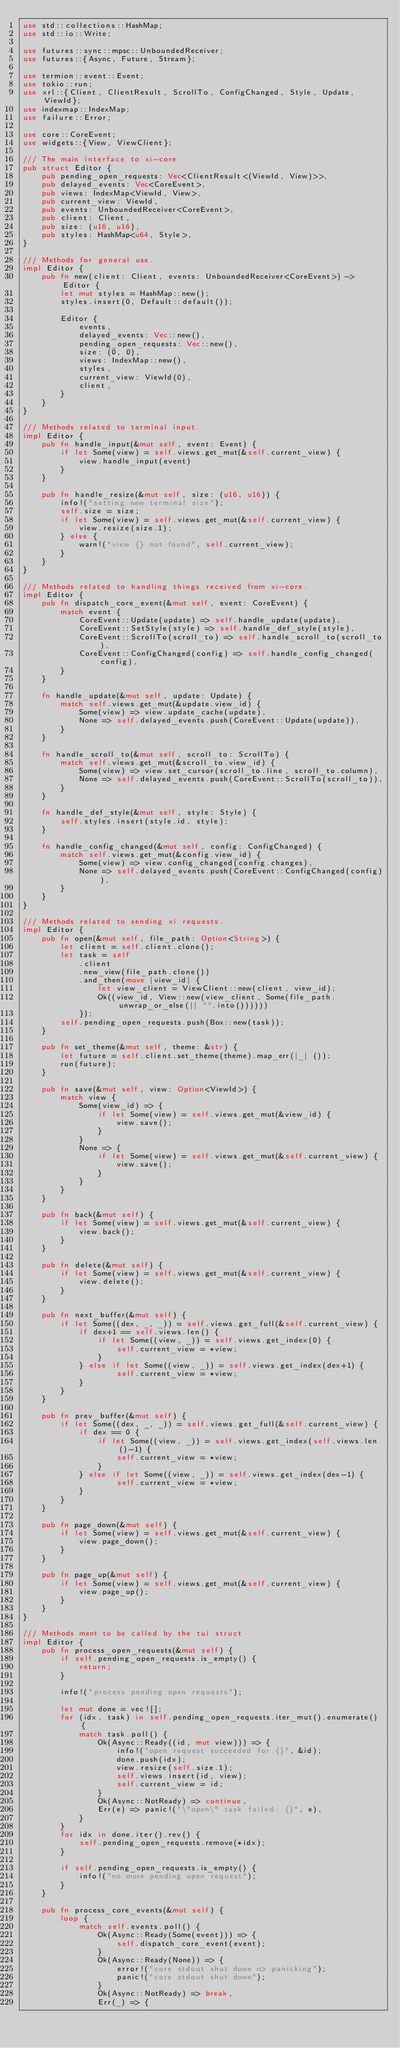Convert code to text. <code><loc_0><loc_0><loc_500><loc_500><_Rust_>use std::collections::HashMap;
use std::io::Write;

use futures::sync::mpsc::UnboundedReceiver;
use futures::{Async, Future, Stream};

use termion::event::Event;
use tokio::run;
use xrl::{Client, ClientResult, ScrollTo, ConfigChanged, Style, Update, ViewId};
use indexmap::IndexMap;
use failure::Error;

use core::CoreEvent;
use widgets::{View, ViewClient};

/// The main interface to xi-core
pub struct Editor {
    pub pending_open_requests: Vec<ClientResult<(ViewId, View)>>,
    pub delayed_events: Vec<CoreEvent>,
    pub views: IndexMap<ViewId, View>,
    pub current_view: ViewId,
    pub events: UnboundedReceiver<CoreEvent>,
    pub client: Client,
    pub size: (u16, u16),
    pub styles: HashMap<u64, Style>,
}

/// Methods for general use.
impl Editor {
    pub fn new(client: Client, events: UnboundedReceiver<CoreEvent>) -> Editor {
        let mut styles = HashMap::new();
        styles.insert(0, Default::default());

        Editor {
            events,
            delayed_events: Vec::new(),
            pending_open_requests: Vec::new(),
            size: (0, 0),
            views: IndexMap::new(),
            styles,
            current_view: ViewId(0),
            client,
        }
    }
}

/// Methods related to terminal input.
impl Editor {
    pub fn handle_input(&mut self, event: Event) {
        if let Some(view) = self.views.get_mut(&self.current_view) {
            view.handle_input(event)
        }
    }

    pub fn handle_resize(&mut self, size: (u16, u16)) {
        info!("setting new terminal size");
        self.size = size;
        if let Some(view) = self.views.get_mut(&self.current_view) {
            view.resize(size.1);
        } else {
            warn!("view {} not found", self.current_view);
        }
    }
}

/// Methods related to handling things received from xi-core.
impl Editor {
    pub fn dispatch_core_event(&mut self, event: CoreEvent) {
        match event {
            CoreEvent::Update(update) => self.handle_update(update),
            CoreEvent::SetStyle(style) => self.handle_def_style(style),
            CoreEvent::ScrollTo(scroll_to) => self.handle_scroll_to(scroll_to),
            CoreEvent::ConfigChanged(config) => self.handle_config_changed(config),
        }
    }

    fn handle_update(&mut self, update: Update) {
        match self.views.get_mut(&update.view_id) {
            Some(view) => view.update_cache(update),
            None => self.delayed_events.push(CoreEvent::Update(update)),
        }
    }

    fn handle_scroll_to(&mut self, scroll_to: ScrollTo) {
        match self.views.get_mut(&scroll_to.view_id) {
            Some(view) => view.set_cursor(scroll_to.line, scroll_to.column),
            None => self.delayed_events.push(CoreEvent::ScrollTo(scroll_to)),
        }
    }

    fn handle_def_style(&mut self, style: Style) {
        self.styles.insert(style.id, style);
    }

    fn handle_config_changed(&mut self, config: ConfigChanged) {
        match self.views.get_mut(&config.view_id) {
            Some(view) => view.config_changed(config.changes),
            None => self.delayed_events.push(CoreEvent::ConfigChanged(config)),
        }
    }
}

/// Methods related to sending xi requests.
impl Editor {
    pub fn open(&mut self, file_path: Option<String>) {
        let client = self.client.clone();
        let task = self
            .client
            .new_view(file_path.clone())
            .and_then(move |view_id| {
                let view_client = ViewClient::new(client, view_id);
                Ok((view_id, View::new(view_client, Some(file_path.unwrap_or_else(|| "".into())))))
            });
        self.pending_open_requests.push(Box::new(task));
    }

    pub fn set_theme(&mut self, theme: &str) {
        let future = self.client.set_theme(theme).map_err(|_| ());
        run(future);
    }

    pub fn save(&mut self, view: Option<ViewId>) {
        match view {
            Some(view_id) => {
                if let Some(view) = self.views.get_mut(&view_id) {
                    view.save();
                }
            }
            None => {
                if let Some(view) = self.views.get_mut(&self.current_view) {
                    view.save();
                }
            }
        }
    }

    pub fn back(&mut self) {
        if let Some(view) = self.views.get_mut(&self.current_view) {
            view.back();
        }
    }

    pub fn delete(&mut self) {
        if let Some(view) = self.views.get_mut(&self.current_view) {
            view.delete();
        }
    }

    pub fn next_buffer(&mut self) {
        if let Some((dex, _, _)) = self.views.get_full(&self.current_view) {
            if dex+1 == self.views.len() {
                if let Some((view, _)) = self.views.get_index(0) {
                    self.current_view = *view;
                }
            } else if let Some((view, _)) = self.views.get_index(dex+1) {
                    self.current_view = *view;
            }
        }
    }

    pub fn prev_buffer(&mut self) {
        if let Some((dex, _, _)) = self.views.get_full(&self.current_view) {
            if dex == 0 {
                if let Some((view, _)) = self.views.get_index(self.views.len()-1) {
                    self.current_view = *view;
                }
            } else if let Some((view, _)) = self.views.get_index(dex-1) {
                    self.current_view = *view;
            }
        }
    }

    pub fn page_down(&mut self) {
        if let Some(view) = self.views.get_mut(&self.current_view) {
            view.page_down();
        }
    }

    pub fn page_up(&mut self) {
        if let Some(view) = self.views.get_mut(&self.current_view) {
            view.page_up();
        }
    }
}

/// Methods ment to be called by the tui struct
impl Editor {
    pub fn process_open_requests(&mut self) {
        if self.pending_open_requests.is_empty() {
            return;
        }

        info!("process pending open requests");

        let mut done = vec![];
        for (idx, task) in self.pending_open_requests.iter_mut().enumerate() {
            match task.poll() {
                Ok(Async::Ready((id, mut view))) => {
                    info!("open request succeeded for {}", &id);
                    done.push(idx);
                    view.resize(self.size.1);
                    self.views.insert(id, view);
                    self.current_view = id;
                }
                Ok(Async::NotReady) => continue,
                Err(e) => panic!("\"open\" task failed: {}", e),
            }
        }
        for idx in done.iter().rev() {
            self.pending_open_requests.remove(*idx);
        }

        if self.pending_open_requests.is_empty() {
            info!("no more pending open request");
        }
    }

    pub fn process_core_events(&mut self) {
        loop {
            match self.events.poll() {
                Ok(Async::Ready(Some(event))) => {
                    self.dispatch_core_event(event);
                }
                Ok(Async::Ready(None)) => {
                    error!("core stdout shut down => panicking");
                    panic!("core stdout shut down");
                }
                Ok(Async::NotReady) => break,
                Err(_) => {</code> 